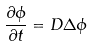Convert formula to latex. <formula><loc_0><loc_0><loc_500><loc_500>\frac { \partial \phi } { \partial t } = D \Delta \phi</formula> 